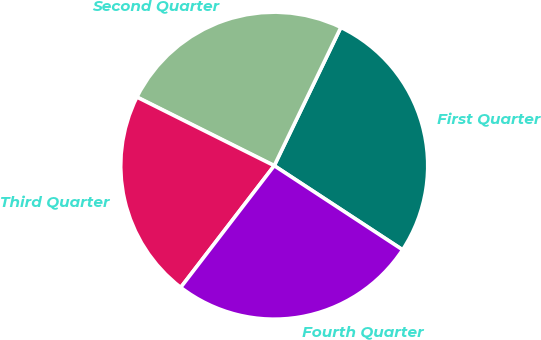Convert chart. <chart><loc_0><loc_0><loc_500><loc_500><pie_chart><fcel>First Quarter<fcel>Second Quarter<fcel>Third Quarter<fcel>Fourth Quarter<nl><fcel>27.09%<fcel>24.77%<fcel>21.95%<fcel>26.19%<nl></chart> 